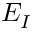Convert formula to latex. <formula><loc_0><loc_0><loc_500><loc_500>E _ { I }</formula> 